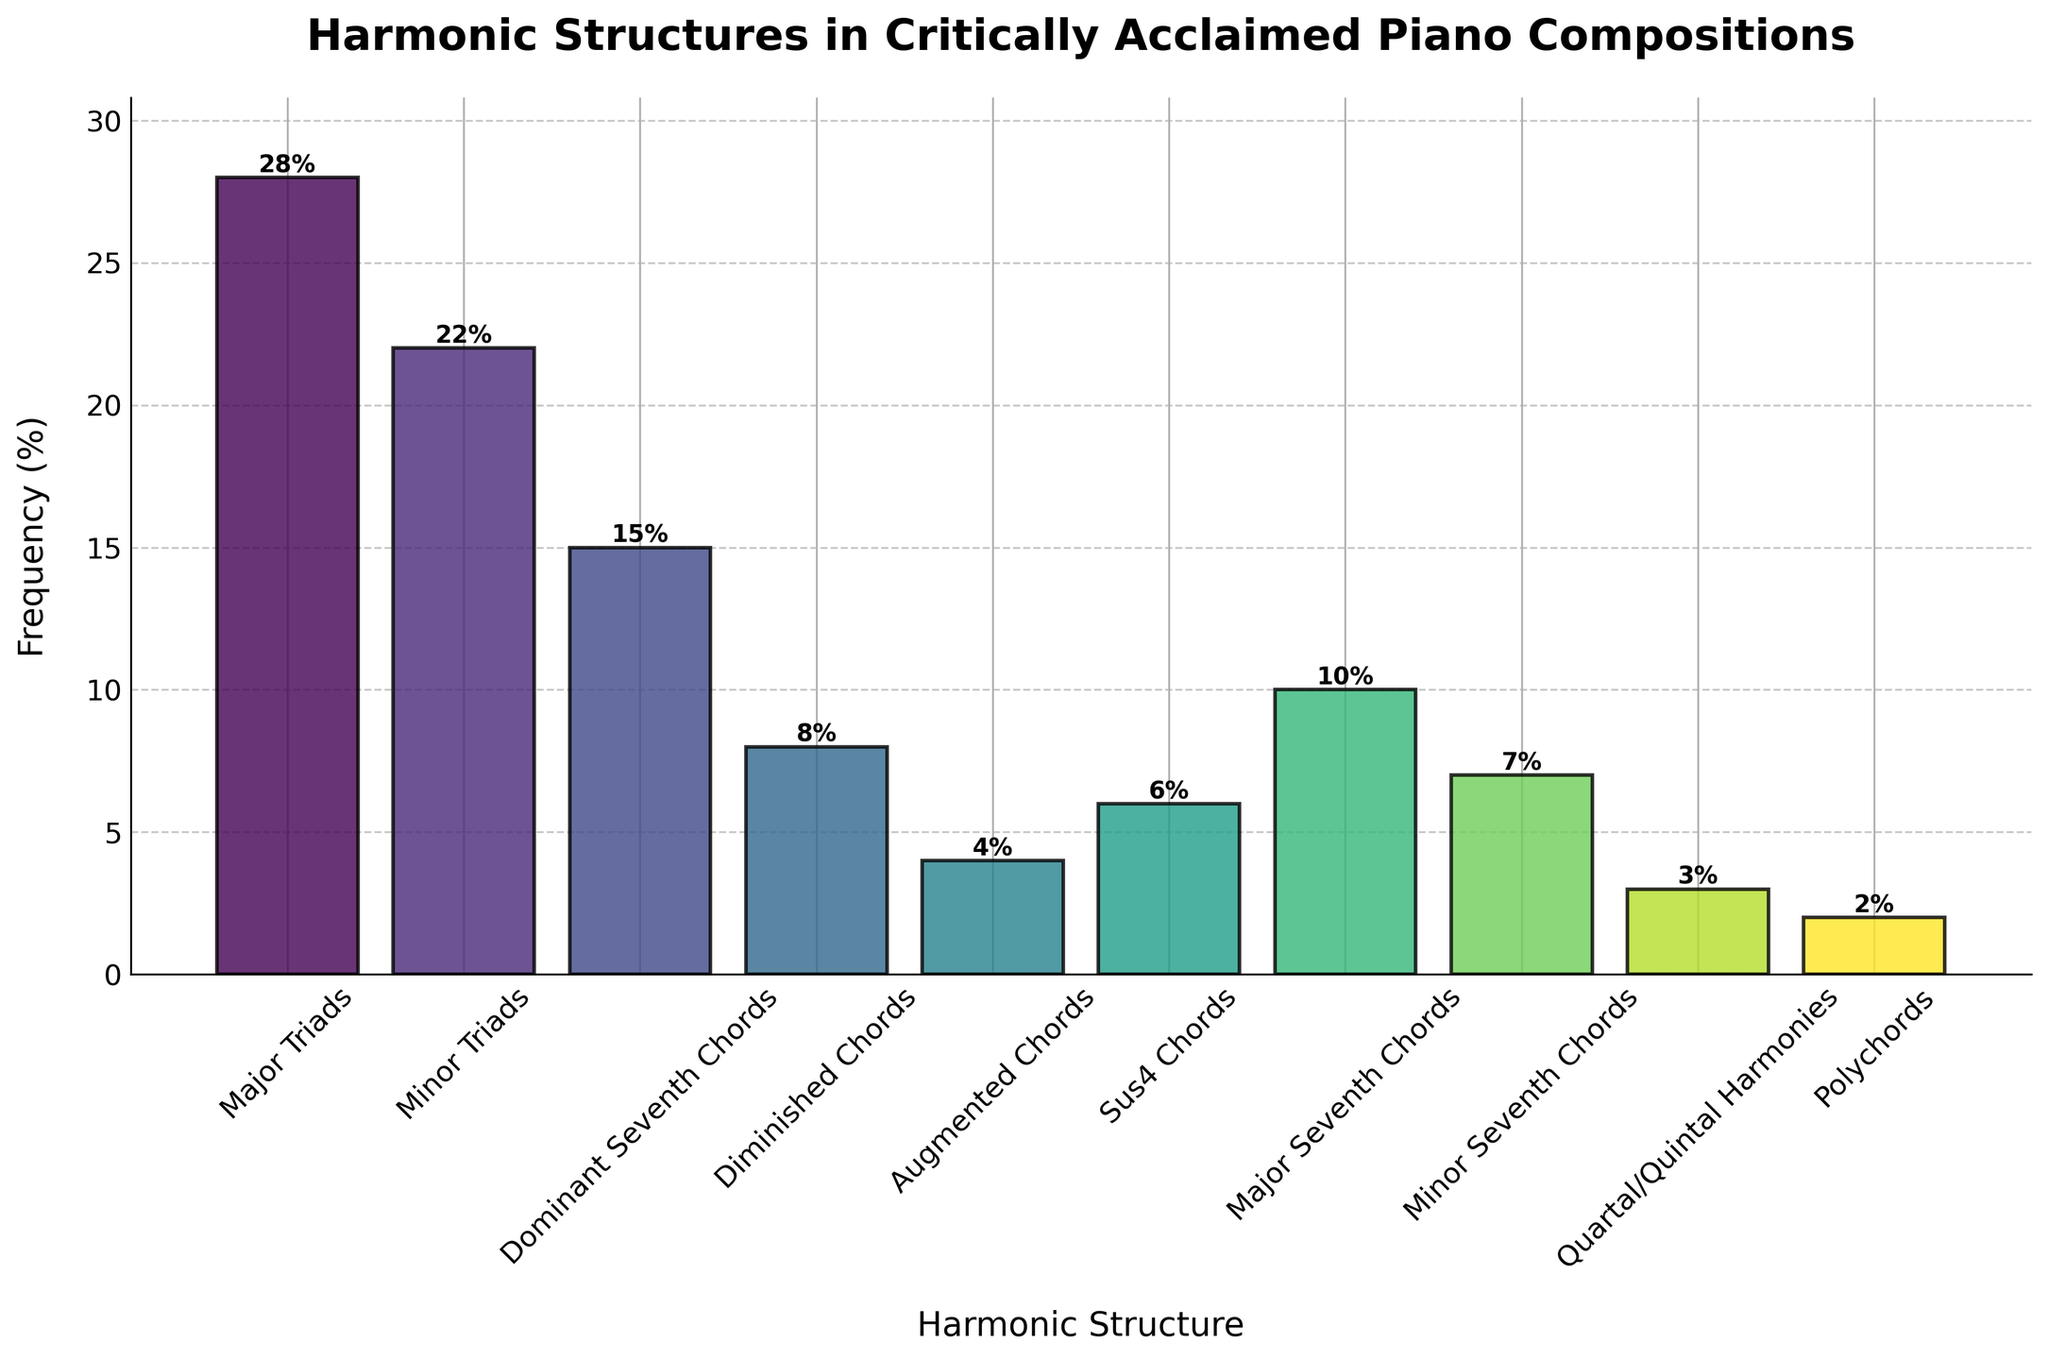What's the most frequently used harmonic structure in critically acclaimed piano compositions? The highest bar represents the most frequently used harmonic structure. The bar labeled "Major Triads" has the highest frequency percentage (28%).
Answer: Major Triads Which harmonic structure is used least often? The shortest bar indicates the least used harmonic structure. The bar labeled "Polychords" has the lowest frequency percentage (2%).
Answer: Polychords What is the sum of the frequencies of Major Triads, Minor Triads, and Dominant Seventh Chords? Sum the frequency percentages of these harmonic structures: Major Triads (28%) + Minor Triads (22%) + Dominant Seventh Chords (15%) = 28 + 22 + 15 = 65.
Answer: 65% How much more frequently are Major Triads used compared to Diminished Chords? Subtract the frequency percentage of Diminished Chords from that of Major Triads: 28% - 8% = 20%.
Answer: 20% Which harmonic structures have a frequency percentage greater than 10%? Identify the bars with heights greater than 10%: Major Triads (28%), Minor Triads (22%), Dominant Seventh Chords (15%), and Major Seventh Chords (10%).
Answer: Major Triads, Minor Triads, Dominant Seventh Chords What is the combined frequency percentage of harmonic structures used less than 10%? Sum the frequency percentages of harmonic structures below 10%: Diminished Chords (8%), Augmented Chords (4%), Sus4 Chords (6%), Minor Seventh Chords (7%), Quartal/Quintal Harmonies (3%), Polychords (2%) = 8 + 4 + 6 + 7 + 3 + 2 = 30.
Answer: 30% Which harmonic structure is used more frequently: Major Seventh Chords or Minor Seventh Chords? Compare the frequency percentages of the two harmonic structures: Major Seventh Chords (10%) vs. Minor Seventh Chords (7%). Major Seventh Chords are used more frequently.
Answer: Major Seventh Chords How much less frequently are Augmented Chords used compared to Sus4 Chords? Subtract the frequency percentage of Augmented Chords from Sus4 Chords: Sus4 Chords (6%) - Augmented Chords (4%) = 2%.
Answer: 2% What percentage of compositions use either Major Triads or Minor Triads? Sum the frequency percentages of Major Triads and Minor Triads: Major Triads (28%) + Minor Triads (22%) = 28 + 22 = 50.
Answer: 50% 